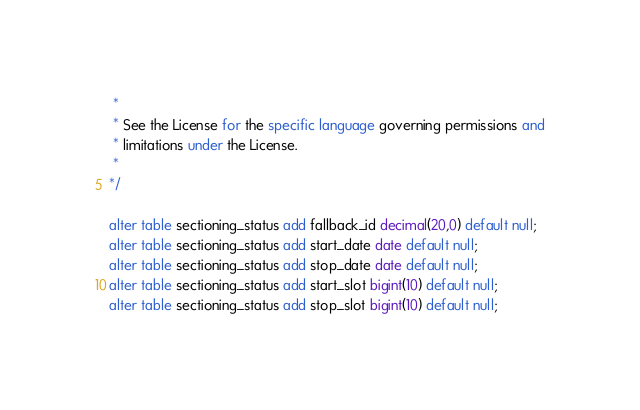Convert code to text. <code><loc_0><loc_0><loc_500><loc_500><_SQL_> *
 * See the License for the specific language governing permissions and
 * limitations under the License.
 *
*/

alter table sectioning_status add fallback_id decimal(20,0) default null;
alter table sectioning_status add start_date date default null;
alter table sectioning_status add stop_date date default null;
alter table sectioning_status add start_slot bigint(10) default null;
alter table sectioning_status add stop_slot bigint(10) default null;
</code> 